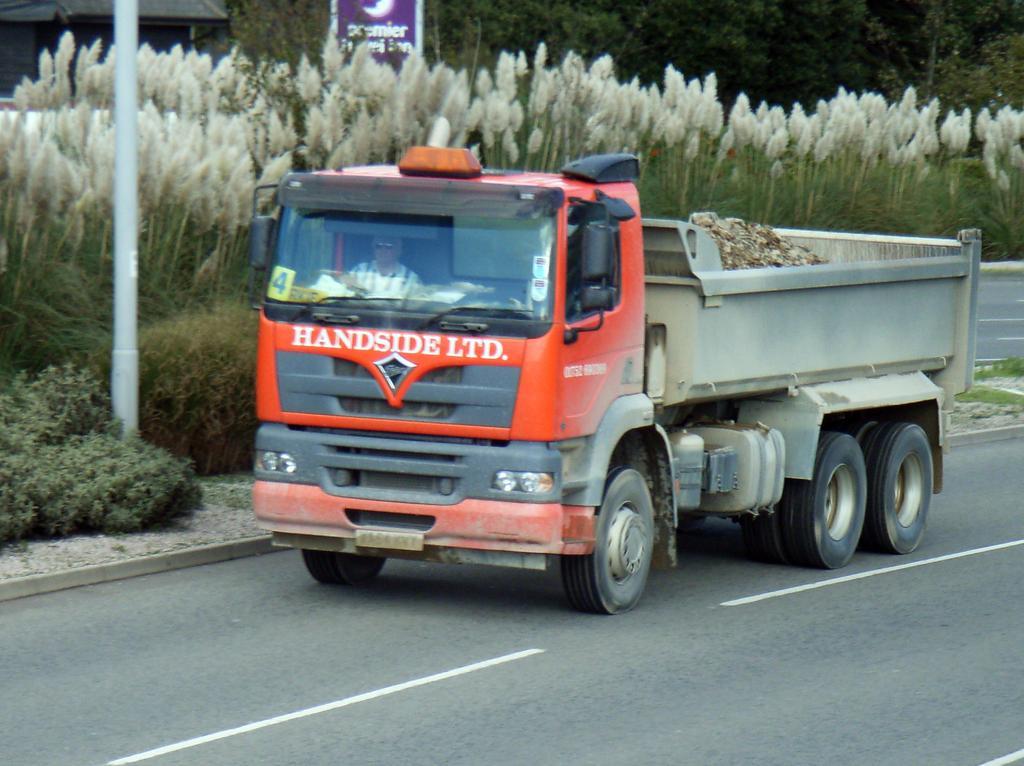In one or two sentences, can you explain what this image depicts? In this image, we can see a truck with a person in it. We can also see the road. On the left, we can see a pole and some plants. We can also see some trees. 